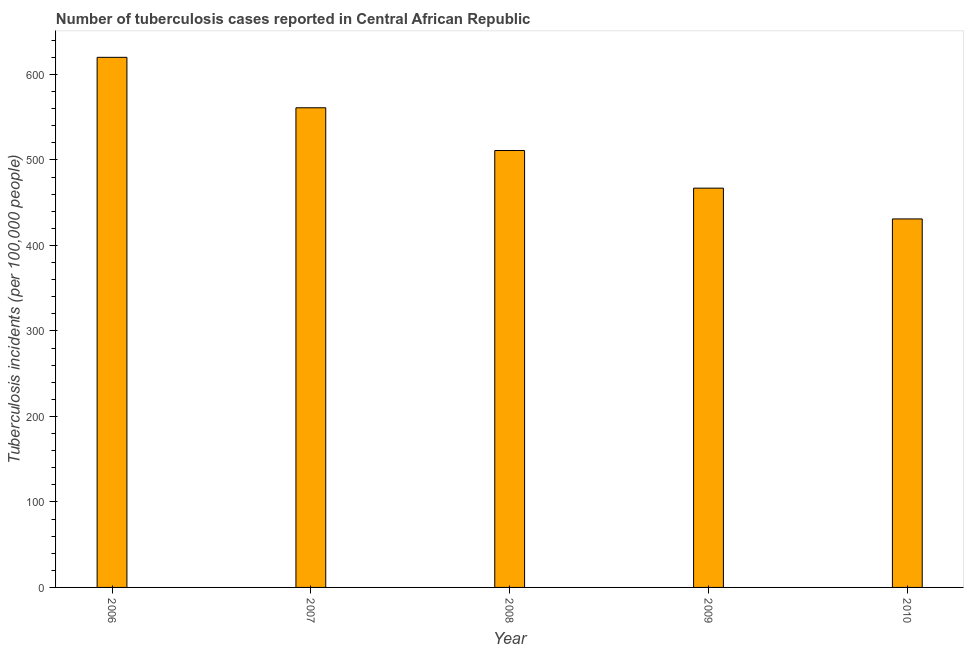What is the title of the graph?
Ensure brevity in your answer.  Number of tuberculosis cases reported in Central African Republic. What is the label or title of the X-axis?
Give a very brief answer. Year. What is the label or title of the Y-axis?
Offer a very short reply. Tuberculosis incidents (per 100,0 people). What is the number of tuberculosis incidents in 2007?
Offer a terse response. 561. Across all years, what is the maximum number of tuberculosis incidents?
Give a very brief answer. 620. Across all years, what is the minimum number of tuberculosis incidents?
Ensure brevity in your answer.  431. In which year was the number of tuberculosis incidents maximum?
Offer a very short reply. 2006. In which year was the number of tuberculosis incidents minimum?
Your answer should be very brief. 2010. What is the sum of the number of tuberculosis incidents?
Offer a very short reply. 2590. What is the difference between the number of tuberculosis incidents in 2006 and 2007?
Make the answer very short. 59. What is the average number of tuberculosis incidents per year?
Your answer should be compact. 518. What is the median number of tuberculosis incidents?
Your response must be concise. 511. In how many years, is the number of tuberculosis incidents greater than 120 ?
Your answer should be very brief. 5. Do a majority of the years between 2006 and 2007 (inclusive) have number of tuberculosis incidents greater than 560 ?
Keep it short and to the point. Yes. What is the ratio of the number of tuberculosis incidents in 2009 to that in 2010?
Offer a very short reply. 1.08. What is the difference between the highest and the second highest number of tuberculosis incidents?
Keep it short and to the point. 59. Is the sum of the number of tuberculosis incidents in 2007 and 2008 greater than the maximum number of tuberculosis incidents across all years?
Offer a very short reply. Yes. What is the difference between the highest and the lowest number of tuberculosis incidents?
Offer a very short reply. 189. How many years are there in the graph?
Offer a terse response. 5. What is the difference between two consecutive major ticks on the Y-axis?
Provide a succinct answer. 100. What is the Tuberculosis incidents (per 100,000 people) of 2006?
Give a very brief answer. 620. What is the Tuberculosis incidents (per 100,000 people) in 2007?
Provide a short and direct response. 561. What is the Tuberculosis incidents (per 100,000 people) in 2008?
Your response must be concise. 511. What is the Tuberculosis incidents (per 100,000 people) in 2009?
Make the answer very short. 467. What is the Tuberculosis incidents (per 100,000 people) in 2010?
Offer a terse response. 431. What is the difference between the Tuberculosis incidents (per 100,000 people) in 2006 and 2008?
Your answer should be compact. 109. What is the difference between the Tuberculosis incidents (per 100,000 people) in 2006 and 2009?
Give a very brief answer. 153. What is the difference between the Tuberculosis incidents (per 100,000 people) in 2006 and 2010?
Provide a short and direct response. 189. What is the difference between the Tuberculosis incidents (per 100,000 people) in 2007 and 2008?
Provide a succinct answer. 50. What is the difference between the Tuberculosis incidents (per 100,000 people) in 2007 and 2009?
Ensure brevity in your answer.  94. What is the difference between the Tuberculosis incidents (per 100,000 people) in 2007 and 2010?
Your response must be concise. 130. What is the difference between the Tuberculosis incidents (per 100,000 people) in 2008 and 2009?
Provide a succinct answer. 44. What is the difference between the Tuberculosis incidents (per 100,000 people) in 2008 and 2010?
Keep it short and to the point. 80. What is the difference between the Tuberculosis incidents (per 100,000 people) in 2009 and 2010?
Make the answer very short. 36. What is the ratio of the Tuberculosis incidents (per 100,000 people) in 2006 to that in 2007?
Keep it short and to the point. 1.1. What is the ratio of the Tuberculosis incidents (per 100,000 people) in 2006 to that in 2008?
Provide a succinct answer. 1.21. What is the ratio of the Tuberculosis incidents (per 100,000 people) in 2006 to that in 2009?
Ensure brevity in your answer.  1.33. What is the ratio of the Tuberculosis incidents (per 100,000 people) in 2006 to that in 2010?
Your answer should be compact. 1.44. What is the ratio of the Tuberculosis incidents (per 100,000 people) in 2007 to that in 2008?
Offer a very short reply. 1.1. What is the ratio of the Tuberculosis incidents (per 100,000 people) in 2007 to that in 2009?
Your answer should be very brief. 1.2. What is the ratio of the Tuberculosis incidents (per 100,000 people) in 2007 to that in 2010?
Your response must be concise. 1.3. What is the ratio of the Tuberculosis incidents (per 100,000 people) in 2008 to that in 2009?
Your answer should be very brief. 1.09. What is the ratio of the Tuberculosis incidents (per 100,000 people) in 2008 to that in 2010?
Give a very brief answer. 1.19. What is the ratio of the Tuberculosis incidents (per 100,000 people) in 2009 to that in 2010?
Ensure brevity in your answer.  1.08. 